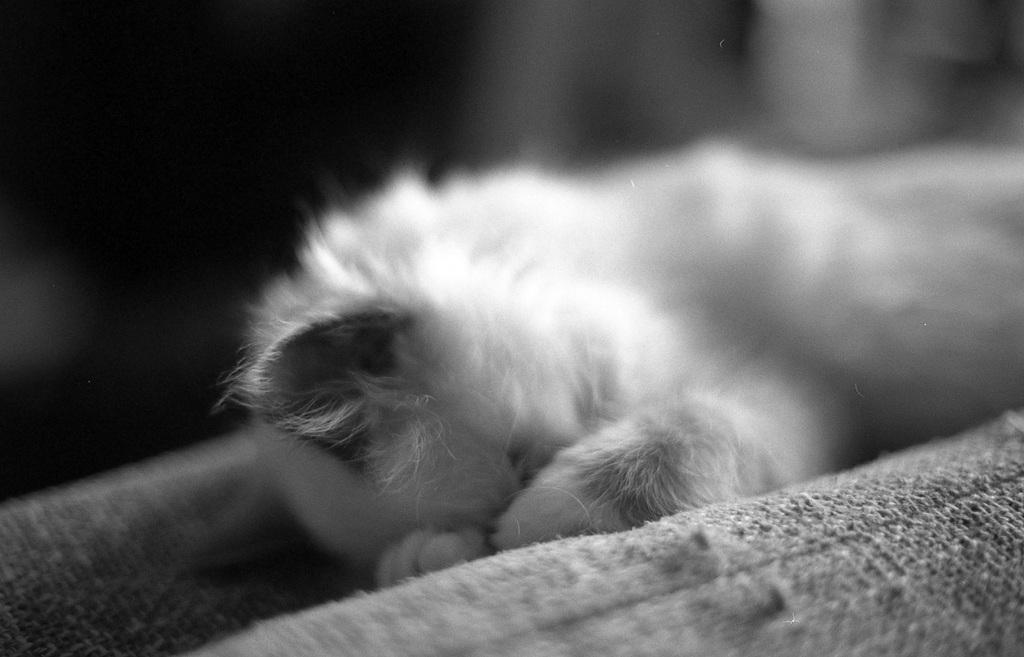How would you summarize this image in a sentence or two? It is the black and white image in which there is an animal sleeping on the bed. 